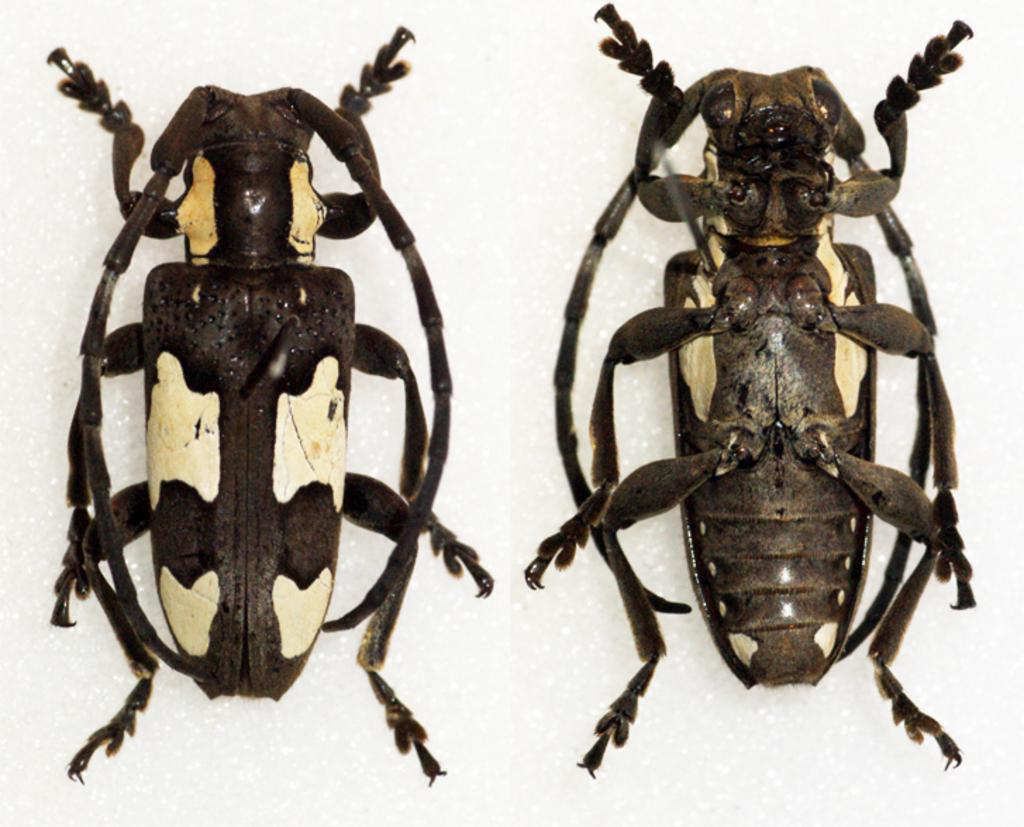What type of artwork is depicted in the image? The image is a collage. How many pictures are included in the collage? There are two pictures within the collage. What is the subject matter of each picture? Each picture contains insects. What is the background color of the pictures? The insects are on a white surface. What type of powder is being used by the committee in the image? There is no committee or powder present in the image; it is a collage featuring pictures of insects on a white surface. 